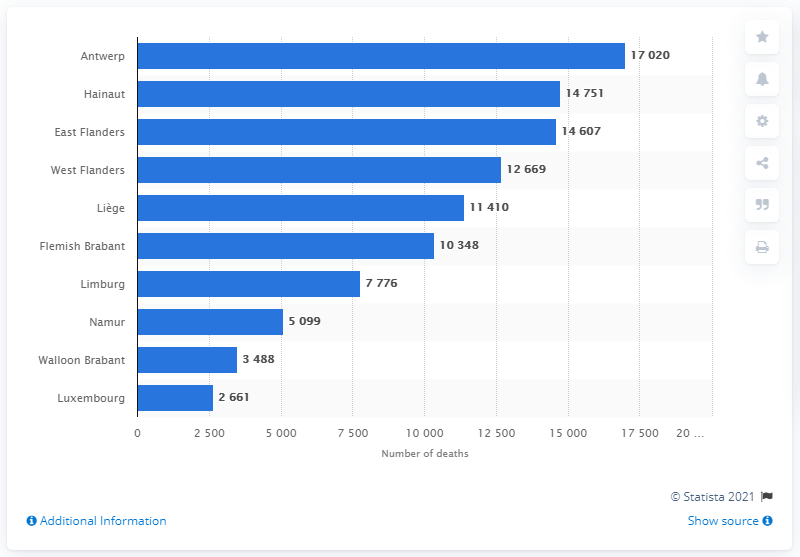Give some essential details in this illustration. In the province of Antwerp in 2019, a total of 17,020 people lost their lives. 